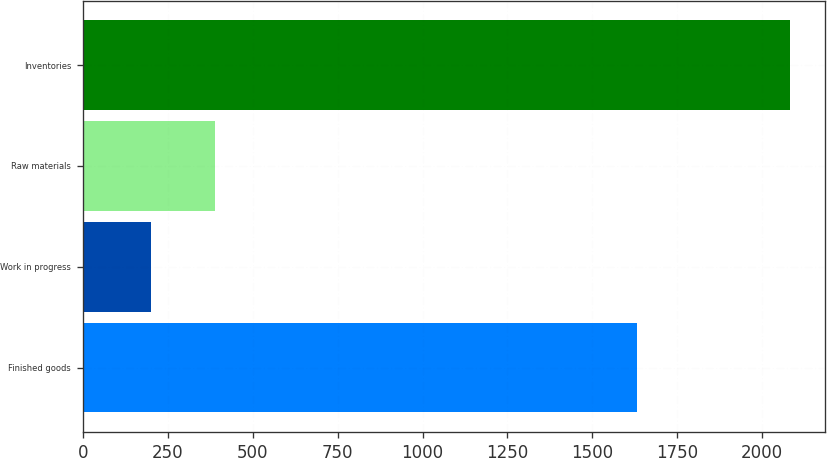Convert chart. <chart><loc_0><loc_0><loc_500><loc_500><bar_chart><fcel>Finished goods<fcel>Work in progress<fcel>Raw materials<fcel>Inventories<nl><fcel>1632.2<fcel>200<fcel>388.18<fcel>2081.8<nl></chart> 